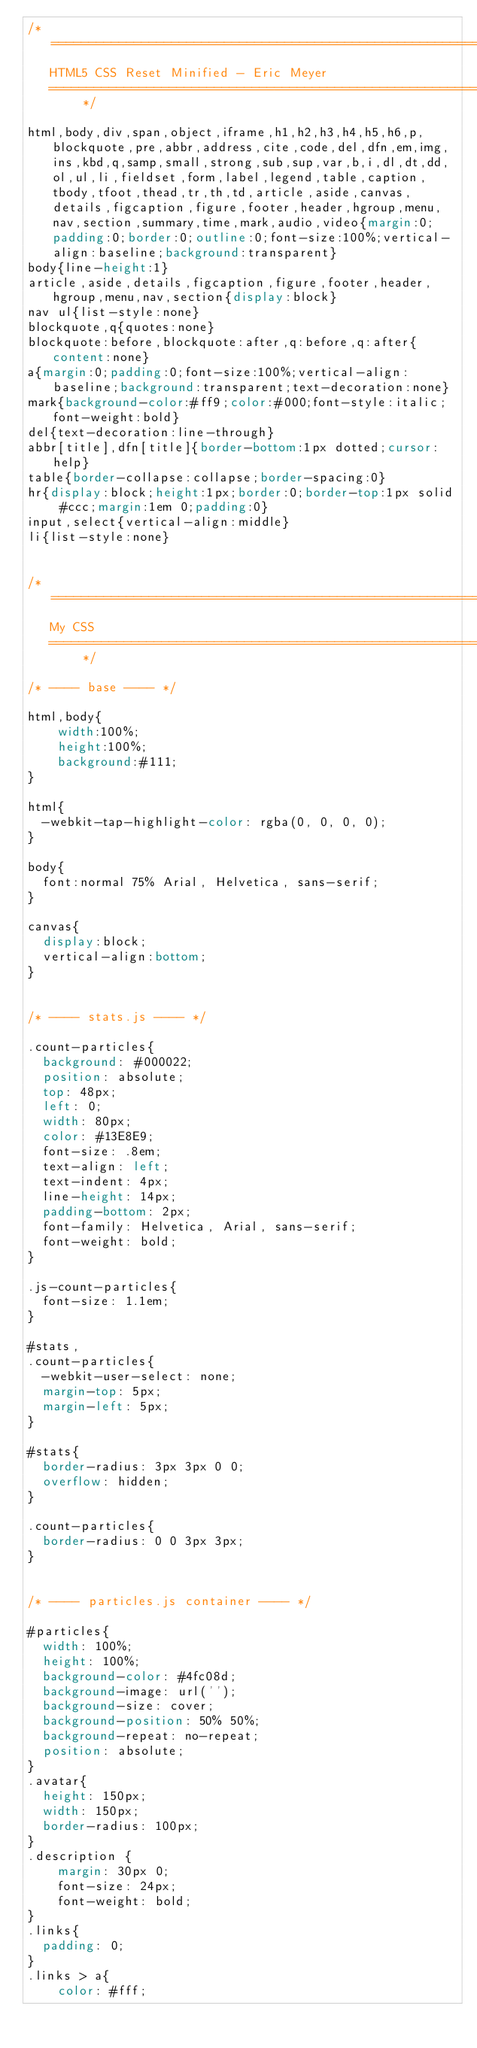<code> <loc_0><loc_0><loc_500><loc_500><_CSS_>/* =============================================================================
   HTML5 CSS Reset Minified - Eric Meyer
   ========================================================================== */

html,body,div,span,object,iframe,h1,h2,h3,h4,h5,h6,p,blockquote,pre,abbr,address,cite,code,del,dfn,em,img,ins,kbd,q,samp,small,strong,sub,sup,var,b,i,dl,dt,dd,ol,ul,li,fieldset,form,label,legend,table,caption,tbody,tfoot,thead,tr,th,td,article,aside,canvas,details,figcaption,figure,footer,header,hgroup,menu,nav,section,summary,time,mark,audio,video{margin:0;padding:0;border:0;outline:0;font-size:100%;vertical-align:baseline;background:transparent}
body{line-height:1}
article,aside,details,figcaption,figure,footer,header,hgroup,menu,nav,section{display:block}
nav ul{list-style:none}
blockquote,q{quotes:none}
blockquote:before,blockquote:after,q:before,q:after{content:none}
a{margin:0;padding:0;font-size:100%;vertical-align:baseline;background:transparent;text-decoration:none}
mark{background-color:#ff9;color:#000;font-style:italic;font-weight:bold}
del{text-decoration:line-through}
abbr[title],dfn[title]{border-bottom:1px dotted;cursor:help}
table{border-collapse:collapse;border-spacing:0}
hr{display:block;height:1px;border:0;border-top:1px solid #ccc;margin:1em 0;padding:0}
input,select{vertical-align:middle}
li{list-style:none}


/* =============================================================================
   My CSS
   ========================================================================== */

/* ---- base ---- */

html,body{ 
	width:100%;
	height:100%;
	background:#111;
}

html{
  -webkit-tap-highlight-color: rgba(0, 0, 0, 0);
}

body{
  font:normal 75% Arial, Helvetica, sans-serif;
}

canvas{
  display:block;
  vertical-align:bottom;
}


/* ---- stats.js ---- */

.count-particles{
  background: #000022;
  position: absolute;
  top: 48px;
  left: 0;
  width: 80px;
  color: #13E8E9;
  font-size: .8em;
  text-align: left;
  text-indent: 4px;
  line-height: 14px;
  padding-bottom: 2px;
  font-family: Helvetica, Arial, sans-serif;
  font-weight: bold;
}

.js-count-particles{
  font-size: 1.1em;
}

#stats,
.count-particles{
  -webkit-user-select: none;
  margin-top: 5px;
  margin-left: 5px;
}

#stats{
  border-radius: 3px 3px 0 0;
  overflow: hidden;
}

.count-particles{
  border-radius: 0 0 3px 3px;
}


/* ---- particles.js container ---- */

#particles{
  width: 100%;
  height: 100%;
  background-color: #4fc08d;
  background-image: url('');
  background-size: cover;
  background-position: 50% 50%;
  background-repeat: no-repeat;
  position: absolute;
}
.avatar{
  height: 150px;
  width: 150px;
  border-radius: 100px;
}
.description {
    margin: 30px 0;
    font-size: 24px;
    font-weight: bold;
}
.links{
  padding: 0;
}
.links > a{
    color: #fff;</code> 